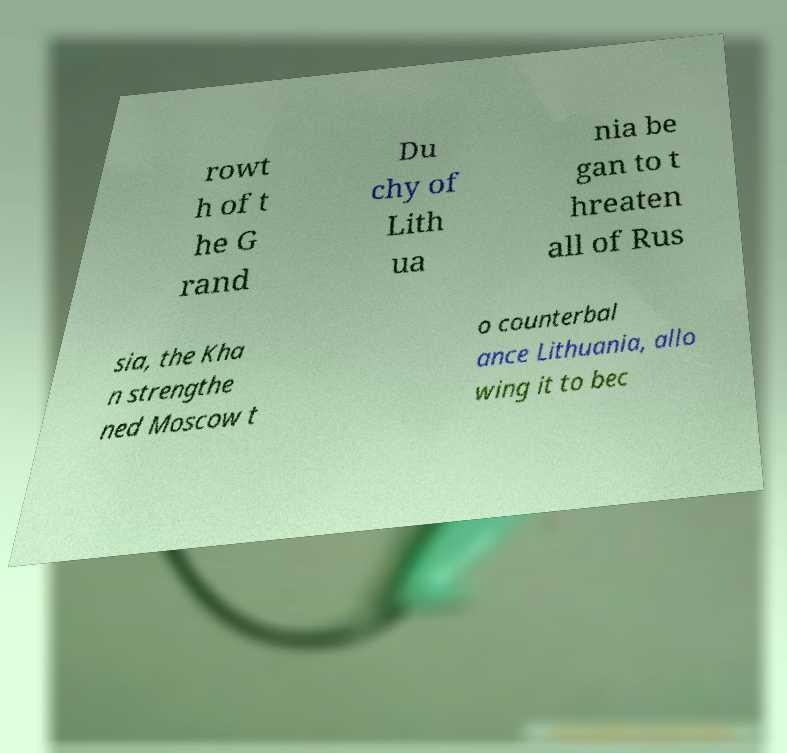Can you read and provide the text displayed in the image?This photo seems to have some interesting text. Can you extract and type it out for me? rowt h of t he G rand Du chy of Lith ua nia be gan to t hreaten all of Rus sia, the Kha n strengthe ned Moscow t o counterbal ance Lithuania, allo wing it to bec 